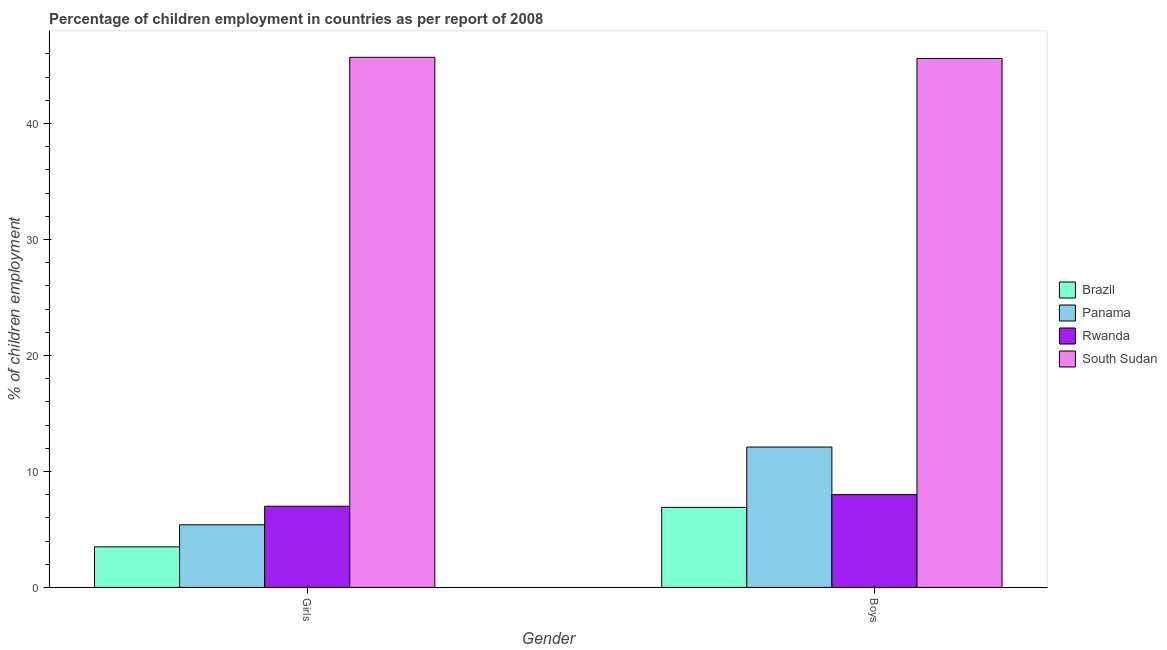How many different coloured bars are there?
Ensure brevity in your answer.  4. Are the number of bars on each tick of the X-axis equal?
Provide a succinct answer. Yes. How many bars are there on the 2nd tick from the left?
Offer a terse response. 4. How many bars are there on the 1st tick from the right?
Your response must be concise. 4. What is the label of the 2nd group of bars from the left?
Give a very brief answer. Boys. Across all countries, what is the maximum percentage of employed girls?
Give a very brief answer. 45.7. In which country was the percentage of employed boys maximum?
Provide a short and direct response. South Sudan. In which country was the percentage of employed boys minimum?
Offer a very short reply. Brazil. What is the total percentage of employed girls in the graph?
Your response must be concise. 61.6. What is the difference between the percentage of employed girls in South Sudan and that in Brazil?
Offer a terse response. 42.2. What is the difference between the percentage of employed boys in Brazil and the percentage of employed girls in South Sudan?
Offer a very short reply. -38.8. What is the average percentage of employed boys per country?
Make the answer very short. 18.15. What is the difference between the percentage of employed boys and percentage of employed girls in Brazil?
Your answer should be very brief. 3.4. In how many countries, is the percentage of employed girls greater than 30 %?
Make the answer very short. 1. What is the ratio of the percentage of employed girls in Brazil to that in South Sudan?
Offer a very short reply. 0.08. Is the percentage of employed boys in Panama less than that in South Sudan?
Provide a succinct answer. Yes. What does the 1st bar from the left in Girls represents?
Make the answer very short. Brazil. What does the 3rd bar from the right in Boys represents?
Your answer should be very brief. Panama. Are all the bars in the graph horizontal?
Keep it short and to the point. No. How many countries are there in the graph?
Provide a succinct answer. 4. What is the difference between two consecutive major ticks on the Y-axis?
Your answer should be compact. 10. Does the graph contain any zero values?
Provide a succinct answer. No. How many legend labels are there?
Your answer should be compact. 4. How are the legend labels stacked?
Keep it short and to the point. Vertical. What is the title of the graph?
Provide a short and direct response. Percentage of children employment in countries as per report of 2008. Does "Korea (Democratic)" appear as one of the legend labels in the graph?
Provide a succinct answer. No. What is the label or title of the X-axis?
Offer a terse response. Gender. What is the label or title of the Y-axis?
Your answer should be very brief. % of children employment. What is the % of children employment in Rwanda in Girls?
Offer a very short reply. 7. What is the % of children employment in South Sudan in Girls?
Keep it short and to the point. 45.7. What is the % of children employment of Brazil in Boys?
Your answer should be compact. 6.9. What is the % of children employment in Rwanda in Boys?
Make the answer very short. 8. What is the % of children employment in South Sudan in Boys?
Provide a succinct answer. 45.6. Across all Gender, what is the maximum % of children employment of Brazil?
Provide a short and direct response. 6.9. Across all Gender, what is the maximum % of children employment of Panama?
Offer a very short reply. 12.1. Across all Gender, what is the maximum % of children employment of Rwanda?
Your answer should be compact. 8. Across all Gender, what is the maximum % of children employment in South Sudan?
Give a very brief answer. 45.7. Across all Gender, what is the minimum % of children employment in Brazil?
Give a very brief answer. 3.5. Across all Gender, what is the minimum % of children employment of Rwanda?
Your response must be concise. 7. Across all Gender, what is the minimum % of children employment of South Sudan?
Provide a short and direct response. 45.6. What is the total % of children employment of Brazil in the graph?
Keep it short and to the point. 10.4. What is the total % of children employment in Panama in the graph?
Provide a short and direct response. 17.5. What is the total % of children employment of Rwanda in the graph?
Your answer should be compact. 15. What is the total % of children employment of South Sudan in the graph?
Keep it short and to the point. 91.3. What is the difference between the % of children employment of Brazil in Girls and that in Boys?
Your answer should be very brief. -3.4. What is the difference between the % of children employment of Panama in Girls and that in Boys?
Provide a succinct answer. -6.7. What is the difference between the % of children employment in Brazil in Girls and the % of children employment in Panama in Boys?
Ensure brevity in your answer.  -8.6. What is the difference between the % of children employment of Brazil in Girls and the % of children employment of South Sudan in Boys?
Ensure brevity in your answer.  -42.1. What is the difference between the % of children employment of Panama in Girls and the % of children employment of South Sudan in Boys?
Provide a succinct answer. -40.2. What is the difference between the % of children employment in Rwanda in Girls and the % of children employment in South Sudan in Boys?
Provide a succinct answer. -38.6. What is the average % of children employment of Panama per Gender?
Offer a very short reply. 8.75. What is the average % of children employment in South Sudan per Gender?
Keep it short and to the point. 45.65. What is the difference between the % of children employment of Brazil and % of children employment of South Sudan in Girls?
Ensure brevity in your answer.  -42.2. What is the difference between the % of children employment of Panama and % of children employment of South Sudan in Girls?
Ensure brevity in your answer.  -40.3. What is the difference between the % of children employment of Rwanda and % of children employment of South Sudan in Girls?
Offer a very short reply. -38.7. What is the difference between the % of children employment in Brazil and % of children employment in Panama in Boys?
Make the answer very short. -5.2. What is the difference between the % of children employment of Brazil and % of children employment of Rwanda in Boys?
Your answer should be very brief. -1.1. What is the difference between the % of children employment in Brazil and % of children employment in South Sudan in Boys?
Offer a very short reply. -38.7. What is the difference between the % of children employment of Panama and % of children employment of Rwanda in Boys?
Offer a terse response. 4.1. What is the difference between the % of children employment in Panama and % of children employment in South Sudan in Boys?
Offer a terse response. -33.5. What is the difference between the % of children employment of Rwanda and % of children employment of South Sudan in Boys?
Make the answer very short. -37.6. What is the ratio of the % of children employment in Brazil in Girls to that in Boys?
Give a very brief answer. 0.51. What is the ratio of the % of children employment of Panama in Girls to that in Boys?
Your answer should be compact. 0.45. What is the ratio of the % of children employment of South Sudan in Girls to that in Boys?
Provide a short and direct response. 1. What is the difference between the highest and the second highest % of children employment of Brazil?
Ensure brevity in your answer.  3.4. What is the difference between the highest and the second highest % of children employment of Panama?
Keep it short and to the point. 6.7. What is the difference between the highest and the second highest % of children employment in Rwanda?
Make the answer very short. 1. What is the difference between the highest and the lowest % of children employment in Brazil?
Your answer should be compact. 3.4. What is the difference between the highest and the lowest % of children employment in South Sudan?
Your answer should be compact. 0.1. 